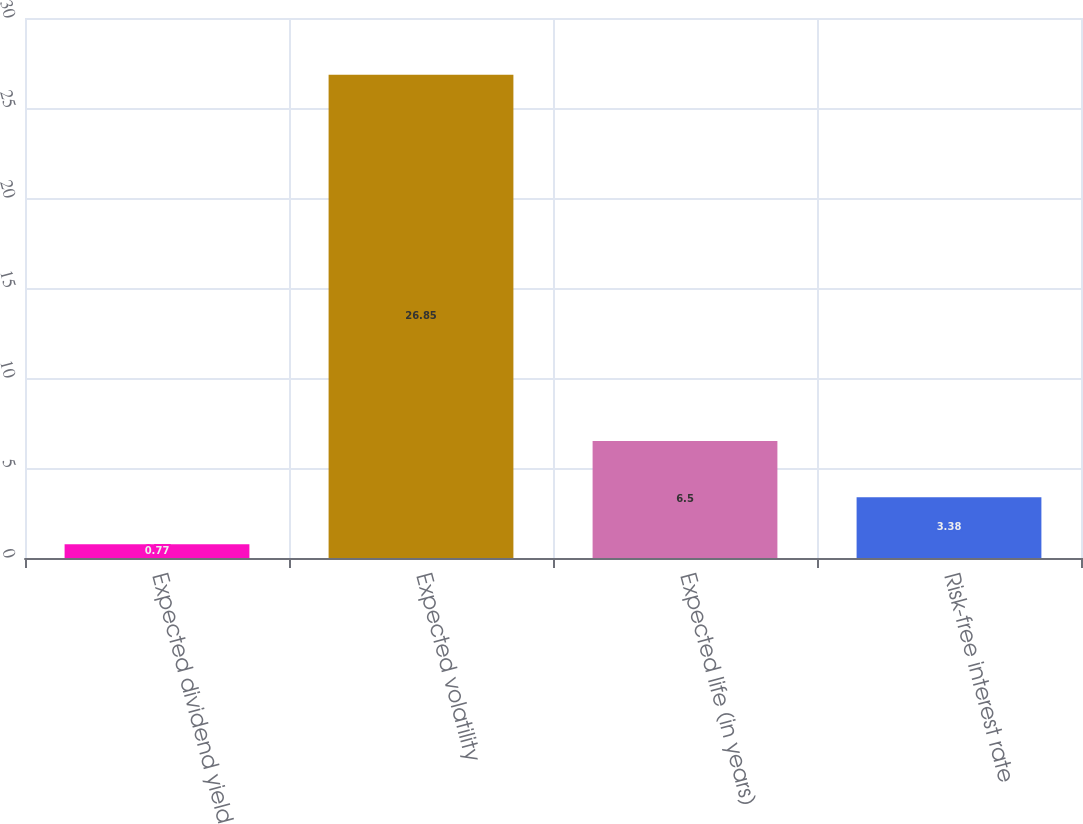Convert chart to OTSL. <chart><loc_0><loc_0><loc_500><loc_500><bar_chart><fcel>Expected dividend yield<fcel>Expected volatility<fcel>Expected life (in years)<fcel>Risk-free interest rate<nl><fcel>0.77<fcel>26.85<fcel>6.5<fcel>3.38<nl></chart> 